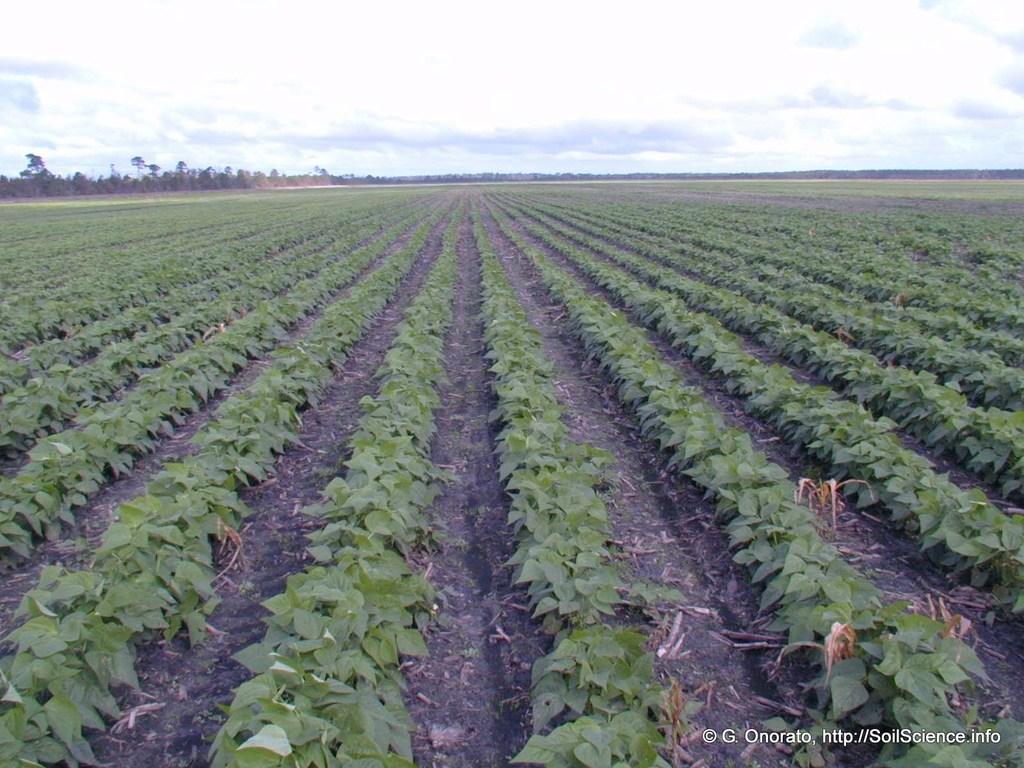Could you give a brief overview of what you see in this image? In the image there is a cultivated land with plants and leaves. In the background there are trees. At the top of the image there is a sky with clouds. In the bottom right corner of the image there is a watermark. 